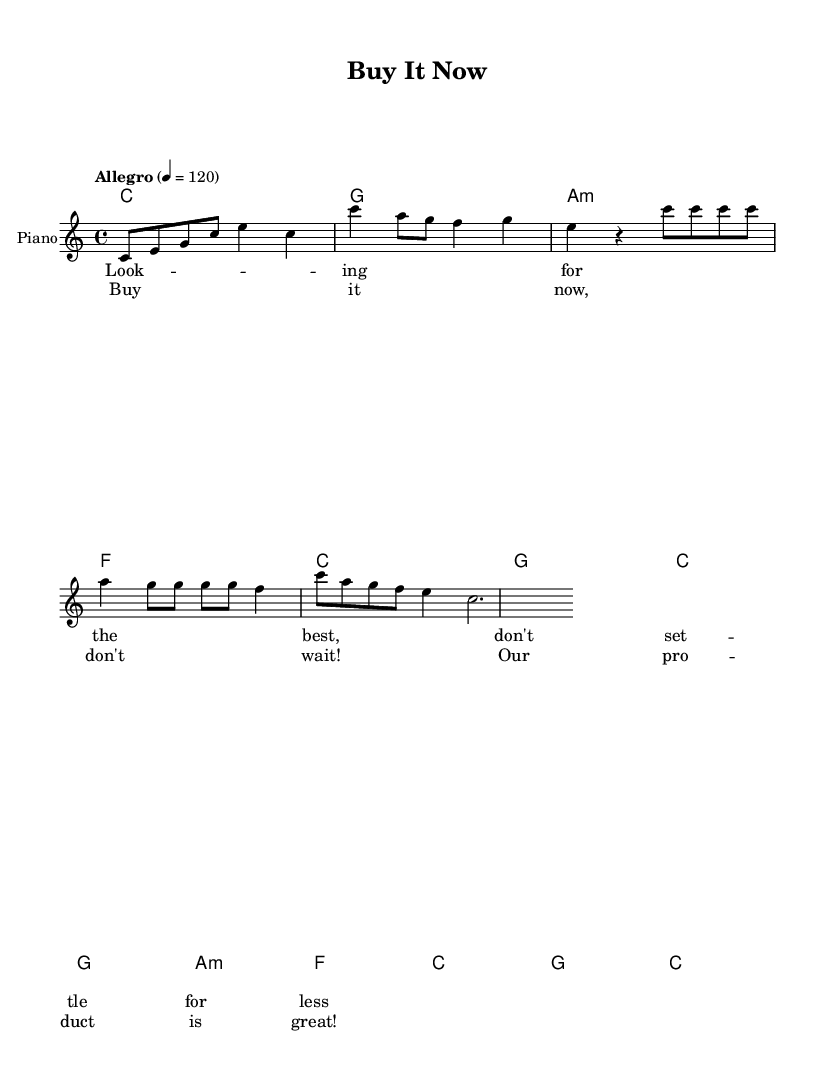What is the key signature of this music? The key signature is C major, indicated by the absence of sharps or flats.
Answer: C major What is the time signature of this music? The time signature is 4/4, which is common for pop music, indicating four beats per measure.
Answer: 4/4 What is the tempo marking of this piece? The tempo marking is "Allegro," which indicates a fast pace of 120 beats per minute.
Answer: Allegro In which section do the lyrics mention "Buy it now, don't wait"? This phrase is found in the chorus, where the song emphasizes the urgency to act.
Answer: Chorus How many measures are in the verse section? The verse section contains four measures, as indicated by the grouping of four beats in each measure.
Answer: 4 What type of chords are primarily used in the verse? The verse utilizes minor chords, particularly A minor, along with major chords like F and C, creating a contrast.
Answer: Minor What is the overall mood suggested by the tempo and key choice in this music? The upbeat tempo and major key suggest a lively and optimistic mood, which is typical for catchy pop music.
Answer: Lively 